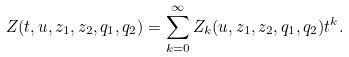Convert formula to latex. <formula><loc_0><loc_0><loc_500><loc_500>Z ( t , u , z _ { 1 } , z _ { 2 } , q _ { 1 } , q _ { 2 } ) = \sum _ { k = 0 } ^ { \infty } Z _ { k } ( u , z _ { 1 } , z _ { 2 } , q _ { 1 } , q _ { 2 } ) t ^ { k } .</formula> 